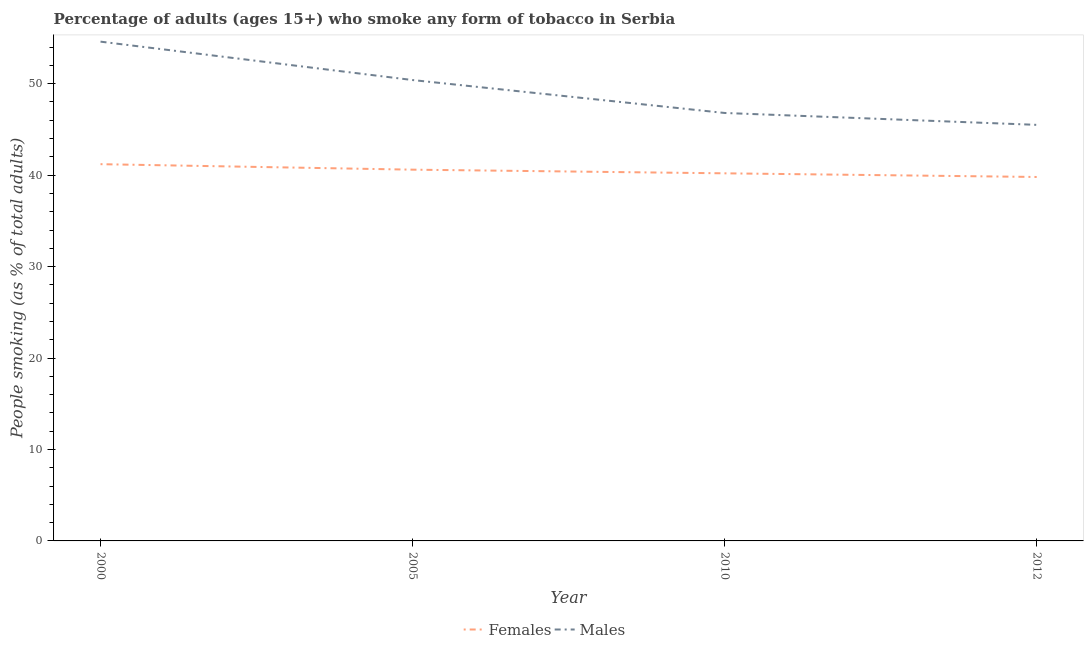Does the line corresponding to percentage of females who smoke intersect with the line corresponding to percentage of males who smoke?
Make the answer very short. No. What is the percentage of males who smoke in 2010?
Ensure brevity in your answer.  46.8. Across all years, what is the maximum percentage of males who smoke?
Offer a terse response. 54.6. Across all years, what is the minimum percentage of males who smoke?
Your answer should be compact. 45.5. In which year was the percentage of males who smoke maximum?
Keep it short and to the point. 2000. In which year was the percentage of males who smoke minimum?
Offer a terse response. 2012. What is the total percentage of males who smoke in the graph?
Make the answer very short. 197.3. What is the difference between the percentage of males who smoke in 2000 and that in 2005?
Give a very brief answer. 4.2. What is the difference between the percentage of females who smoke in 2005 and the percentage of males who smoke in 2010?
Make the answer very short. -6.2. What is the average percentage of males who smoke per year?
Make the answer very short. 49.33. In the year 2012, what is the difference between the percentage of females who smoke and percentage of males who smoke?
Offer a terse response. -5.7. In how many years, is the percentage of females who smoke greater than 2 %?
Make the answer very short. 4. What is the ratio of the percentage of males who smoke in 2005 to that in 2010?
Provide a succinct answer. 1.08. Is the difference between the percentage of females who smoke in 2005 and 2010 greater than the difference between the percentage of males who smoke in 2005 and 2010?
Keep it short and to the point. No. What is the difference between the highest and the second highest percentage of males who smoke?
Give a very brief answer. 4.2. What is the difference between the highest and the lowest percentage of males who smoke?
Keep it short and to the point. 9.1. In how many years, is the percentage of males who smoke greater than the average percentage of males who smoke taken over all years?
Offer a terse response. 2. Does the percentage of males who smoke monotonically increase over the years?
Give a very brief answer. No. Is the percentage of males who smoke strictly less than the percentage of females who smoke over the years?
Ensure brevity in your answer.  No. What is the difference between two consecutive major ticks on the Y-axis?
Give a very brief answer. 10. Does the graph contain grids?
Offer a terse response. No. Where does the legend appear in the graph?
Make the answer very short. Bottom center. How are the legend labels stacked?
Keep it short and to the point. Horizontal. What is the title of the graph?
Ensure brevity in your answer.  Percentage of adults (ages 15+) who smoke any form of tobacco in Serbia. Does "Exports" appear as one of the legend labels in the graph?
Your response must be concise. No. What is the label or title of the X-axis?
Your answer should be very brief. Year. What is the label or title of the Y-axis?
Your response must be concise. People smoking (as % of total adults). What is the People smoking (as % of total adults) of Females in 2000?
Your answer should be very brief. 41.2. What is the People smoking (as % of total adults) in Males in 2000?
Your answer should be compact. 54.6. What is the People smoking (as % of total adults) of Females in 2005?
Ensure brevity in your answer.  40.6. What is the People smoking (as % of total adults) in Males in 2005?
Your response must be concise. 50.4. What is the People smoking (as % of total adults) of Females in 2010?
Provide a succinct answer. 40.2. What is the People smoking (as % of total adults) of Males in 2010?
Make the answer very short. 46.8. What is the People smoking (as % of total adults) in Females in 2012?
Keep it short and to the point. 39.8. What is the People smoking (as % of total adults) in Males in 2012?
Your answer should be compact. 45.5. Across all years, what is the maximum People smoking (as % of total adults) of Females?
Offer a terse response. 41.2. Across all years, what is the maximum People smoking (as % of total adults) of Males?
Provide a short and direct response. 54.6. Across all years, what is the minimum People smoking (as % of total adults) of Females?
Offer a terse response. 39.8. Across all years, what is the minimum People smoking (as % of total adults) in Males?
Make the answer very short. 45.5. What is the total People smoking (as % of total adults) in Females in the graph?
Keep it short and to the point. 161.8. What is the total People smoking (as % of total adults) in Males in the graph?
Offer a very short reply. 197.3. What is the difference between the People smoking (as % of total adults) of Females in 2000 and that in 2005?
Your response must be concise. 0.6. What is the difference between the People smoking (as % of total adults) in Females in 2000 and that in 2010?
Ensure brevity in your answer.  1. What is the difference between the People smoking (as % of total adults) of Females in 2000 and that in 2012?
Give a very brief answer. 1.4. What is the difference between the People smoking (as % of total adults) of Males in 2005 and that in 2010?
Your answer should be compact. 3.6. What is the difference between the People smoking (as % of total adults) of Females in 2005 and that in 2012?
Give a very brief answer. 0.8. What is the difference between the People smoking (as % of total adults) in Females in 2000 and the People smoking (as % of total adults) in Males in 2005?
Your response must be concise. -9.2. What is the difference between the People smoking (as % of total adults) in Females in 2000 and the People smoking (as % of total adults) in Males in 2010?
Give a very brief answer. -5.6. What is the difference between the People smoking (as % of total adults) of Females in 2005 and the People smoking (as % of total adults) of Males in 2010?
Keep it short and to the point. -6.2. What is the difference between the People smoking (as % of total adults) in Females in 2005 and the People smoking (as % of total adults) in Males in 2012?
Offer a very short reply. -4.9. What is the difference between the People smoking (as % of total adults) of Females in 2010 and the People smoking (as % of total adults) of Males in 2012?
Give a very brief answer. -5.3. What is the average People smoking (as % of total adults) of Females per year?
Provide a short and direct response. 40.45. What is the average People smoking (as % of total adults) of Males per year?
Provide a short and direct response. 49.33. In the year 2005, what is the difference between the People smoking (as % of total adults) of Females and People smoking (as % of total adults) of Males?
Your answer should be very brief. -9.8. In the year 2010, what is the difference between the People smoking (as % of total adults) of Females and People smoking (as % of total adults) of Males?
Ensure brevity in your answer.  -6.6. In the year 2012, what is the difference between the People smoking (as % of total adults) of Females and People smoking (as % of total adults) of Males?
Provide a short and direct response. -5.7. What is the ratio of the People smoking (as % of total adults) of Females in 2000 to that in 2005?
Provide a short and direct response. 1.01. What is the ratio of the People smoking (as % of total adults) of Males in 2000 to that in 2005?
Make the answer very short. 1.08. What is the ratio of the People smoking (as % of total adults) in Females in 2000 to that in 2010?
Provide a short and direct response. 1.02. What is the ratio of the People smoking (as % of total adults) in Males in 2000 to that in 2010?
Your answer should be very brief. 1.17. What is the ratio of the People smoking (as % of total adults) in Females in 2000 to that in 2012?
Provide a short and direct response. 1.04. What is the ratio of the People smoking (as % of total adults) in Females in 2005 to that in 2010?
Provide a short and direct response. 1.01. What is the ratio of the People smoking (as % of total adults) of Males in 2005 to that in 2010?
Ensure brevity in your answer.  1.08. What is the ratio of the People smoking (as % of total adults) in Females in 2005 to that in 2012?
Offer a terse response. 1.02. What is the ratio of the People smoking (as % of total adults) in Males in 2005 to that in 2012?
Provide a succinct answer. 1.11. What is the ratio of the People smoking (as % of total adults) in Females in 2010 to that in 2012?
Provide a succinct answer. 1.01. What is the ratio of the People smoking (as % of total adults) in Males in 2010 to that in 2012?
Your answer should be very brief. 1.03. What is the difference between the highest and the second highest People smoking (as % of total adults) of Females?
Your response must be concise. 0.6. What is the difference between the highest and the lowest People smoking (as % of total adults) in Females?
Your answer should be compact. 1.4. 